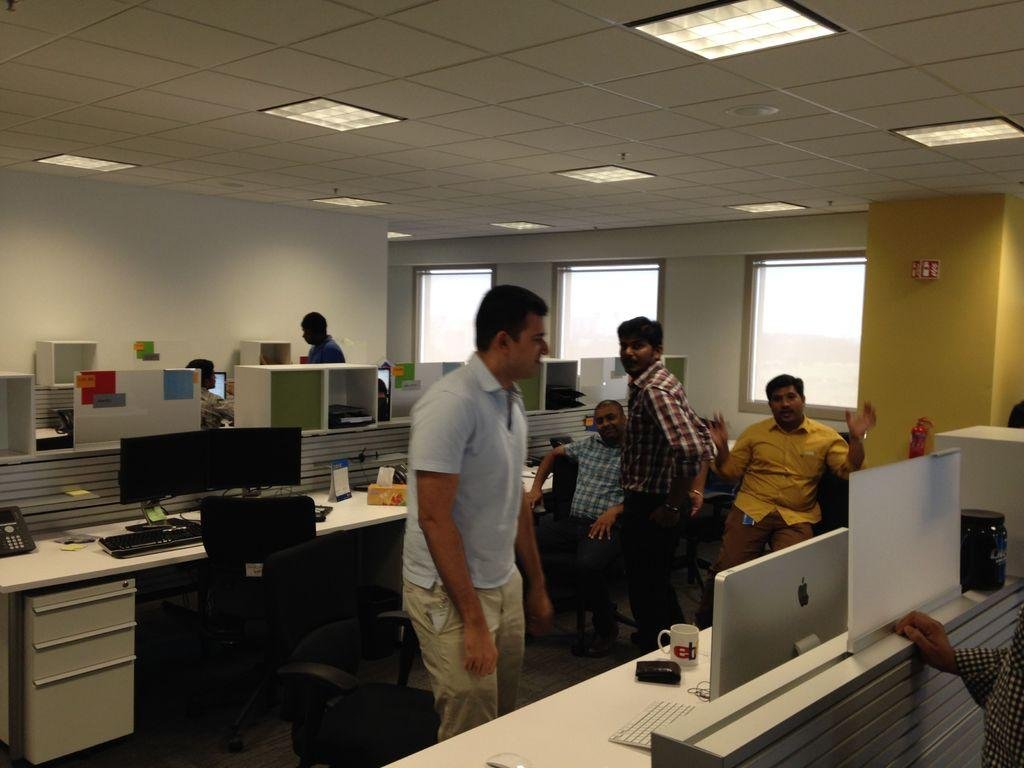How many people are present in the image? There are four people in the image, two standing on either side of the table and two sitting in the background. What are the people standing near the table doing? The people standing near the table are likely interacting with the desktops on the table. Can you describe the table in the image? The table has desktops on it. What type of leg is visible in the image? There is no leg visible in the image; it only features people standing or sitting near a table with desktops on it. 